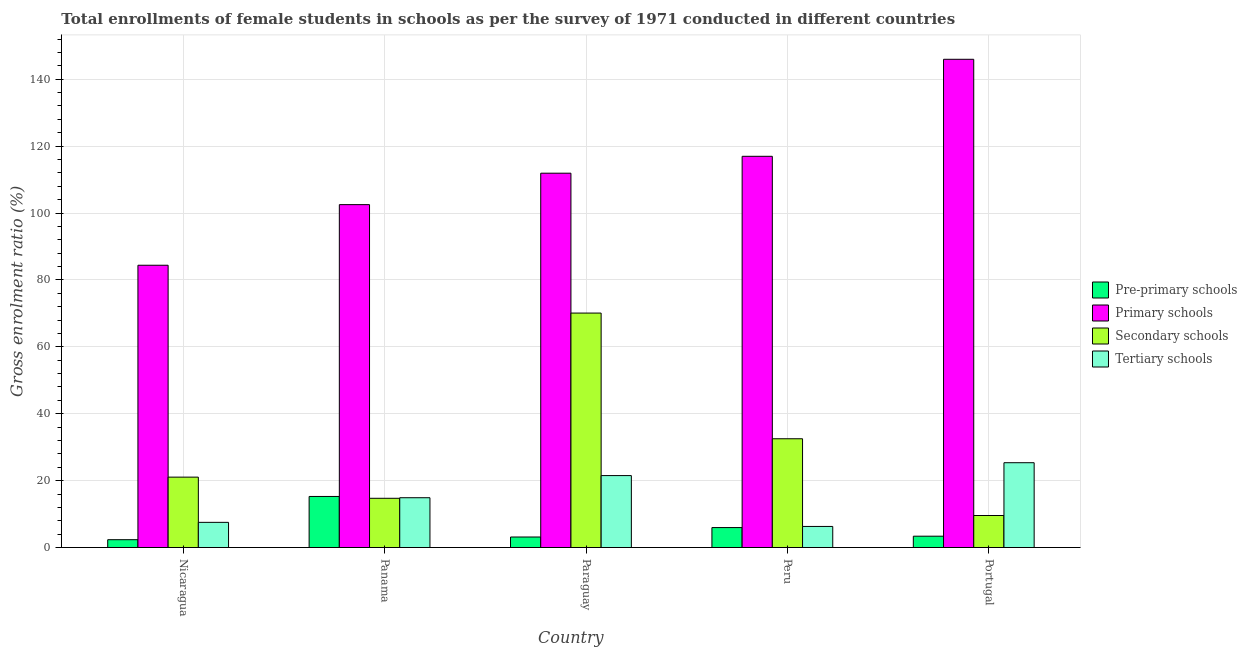How many different coloured bars are there?
Your response must be concise. 4. How many groups of bars are there?
Your answer should be very brief. 5. Are the number of bars on each tick of the X-axis equal?
Offer a terse response. Yes. How many bars are there on the 3rd tick from the left?
Keep it short and to the point. 4. What is the label of the 2nd group of bars from the left?
Your response must be concise. Panama. What is the gross enrolment ratio(female) in primary schools in Nicaragua?
Ensure brevity in your answer.  84.39. Across all countries, what is the maximum gross enrolment ratio(female) in secondary schools?
Offer a very short reply. 70.09. Across all countries, what is the minimum gross enrolment ratio(female) in secondary schools?
Keep it short and to the point. 9.57. In which country was the gross enrolment ratio(female) in pre-primary schools maximum?
Provide a succinct answer. Panama. In which country was the gross enrolment ratio(female) in primary schools minimum?
Your response must be concise. Nicaragua. What is the total gross enrolment ratio(female) in pre-primary schools in the graph?
Give a very brief answer. 30.1. What is the difference between the gross enrolment ratio(female) in secondary schools in Nicaragua and that in Peru?
Your response must be concise. -11.47. What is the difference between the gross enrolment ratio(female) in primary schools in Nicaragua and the gross enrolment ratio(female) in tertiary schools in Panama?
Offer a very short reply. 69.5. What is the average gross enrolment ratio(female) in primary schools per country?
Provide a short and direct response. 112.34. What is the difference between the gross enrolment ratio(female) in tertiary schools and gross enrolment ratio(female) in secondary schools in Panama?
Keep it short and to the point. 0.17. In how many countries, is the gross enrolment ratio(female) in pre-primary schools greater than 148 %?
Keep it short and to the point. 0. What is the ratio of the gross enrolment ratio(female) in tertiary schools in Panama to that in Portugal?
Make the answer very short. 0.59. Is the difference between the gross enrolment ratio(female) in tertiary schools in Nicaragua and Portugal greater than the difference between the gross enrolment ratio(female) in secondary schools in Nicaragua and Portugal?
Your answer should be very brief. No. What is the difference between the highest and the second highest gross enrolment ratio(female) in tertiary schools?
Keep it short and to the point. 3.85. What is the difference between the highest and the lowest gross enrolment ratio(female) in tertiary schools?
Your answer should be very brief. 19.05. In how many countries, is the gross enrolment ratio(female) in pre-primary schools greater than the average gross enrolment ratio(female) in pre-primary schools taken over all countries?
Make the answer very short. 1. Is it the case that in every country, the sum of the gross enrolment ratio(female) in pre-primary schools and gross enrolment ratio(female) in tertiary schools is greater than the sum of gross enrolment ratio(female) in secondary schools and gross enrolment ratio(female) in primary schools?
Your response must be concise. No. What does the 3rd bar from the left in Nicaragua represents?
Give a very brief answer. Secondary schools. What does the 4th bar from the right in Paraguay represents?
Make the answer very short. Pre-primary schools. How many bars are there?
Your answer should be very brief. 20. What is the difference between two consecutive major ticks on the Y-axis?
Ensure brevity in your answer.  20. Does the graph contain any zero values?
Give a very brief answer. No. Does the graph contain grids?
Your response must be concise. Yes. Where does the legend appear in the graph?
Make the answer very short. Center right. What is the title of the graph?
Offer a very short reply. Total enrollments of female students in schools as per the survey of 1971 conducted in different countries. What is the label or title of the Y-axis?
Your response must be concise. Gross enrolment ratio (%). What is the Gross enrolment ratio (%) in Pre-primary schools in Nicaragua?
Your answer should be very brief. 2.34. What is the Gross enrolment ratio (%) of Primary schools in Nicaragua?
Provide a short and direct response. 84.39. What is the Gross enrolment ratio (%) in Secondary schools in Nicaragua?
Your answer should be compact. 21.04. What is the Gross enrolment ratio (%) in Tertiary schools in Nicaragua?
Keep it short and to the point. 7.53. What is the Gross enrolment ratio (%) in Pre-primary schools in Panama?
Your answer should be very brief. 15.27. What is the Gross enrolment ratio (%) of Primary schools in Panama?
Your answer should be compact. 102.51. What is the Gross enrolment ratio (%) in Secondary schools in Panama?
Provide a short and direct response. 14.72. What is the Gross enrolment ratio (%) of Tertiary schools in Panama?
Keep it short and to the point. 14.89. What is the Gross enrolment ratio (%) in Pre-primary schools in Paraguay?
Ensure brevity in your answer.  3.14. What is the Gross enrolment ratio (%) in Primary schools in Paraguay?
Ensure brevity in your answer.  111.91. What is the Gross enrolment ratio (%) of Secondary schools in Paraguay?
Give a very brief answer. 70.09. What is the Gross enrolment ratio (%) of Tertiary schools in Paraguay?
Provide a succinct answer. 21.51. What is the Gross enrolment ratio (%) of Pre-primary schools in Peru?
Make the answer very short. 5.96. What is the Gross enrolment ratio (%) in Primary schools in Peru?
Give a very brief answer. 116.96. What is the Gross enrolment ratio (%) of Secondary schools in Peru?
Your response must be concise. 32.52. What is the Gross enrolment ratio (%) in Tertiary schools in Peru?
Keep it short and to the point. 6.3. What is the Gross enrolment ratio (%) of Pre-primary schools in Portugal?
Your answer should be compact. 3.39. What is the Gross enrolment ratio (%) in Primary schools in Portugal?
Give a very brief answer. 145.96. What is the Gross enrolment ratio (%) of Secondary schools in Portugal?
Your response must be concise. 9.57. What is the Gross enrolment ratio (%) of Tertiary schools in Portugal?
Provide a succinct answer. 25.35. Across all countries, what is the maximum Gross enrolment ratio (%) of Pre-primary schools?
Your answer should be compact. 15.27. Across all countries, what is the maximum Gross enrolment ratio (%) of Primary schools?
Provide a succinct answer. 145.96. Across all countries, what is the maximum Gross enrolment ratio (%) in Secondary schools?
Offer a very short reply. 70.09. Across all countries, what is the maximum Gross enrolment ratio (%) in Tertiary schools?
Provide a succinct answer. 25.35. Across all countries, what is the minimum Gross enrolment ratio (%) of Pre-primary schools?
Your response must be concise. 2.34. Across all countries, what is the minimum Gross enrolment ratio (%) of Primary schools?
Your answer should be very brief. 84.39. Across all countries, what is the minimum Gross enrolment ratio (%) of Secondary schools?
Offer a terse response. 9.57. Across all countries, what is the minimum Gross enrolment ratio (%) of Tertiary schools?
Your answer should be very brief. 6.3. What is the total Gross enrolment ratio (%) in Pre-primary schools in the graph?
Keep it short and to the point. 30.1. What is the total Gross enrolment ratio (%) in Primary schools in the graph?
Keep it short and to the point. 561.72. What is the total Gross enrolment ratio (%) of Secondary schools in the graph?
Ensure brevity in your answer.  147.94. What is the total Gross enrolment ratio (%) of Tertiary schools in the graph?
Offer a terse response. 75.57. What is the difference between the Gross enrolment ratio (%) of Pre-primary schools in Nicaragua and that in Panama?
Provide a short and direct response. -12.93. What is the difference between the Gross enrolment ratio (%) of Primary schools in Nicaragua and that in Panama?
Offer a very short reply. -18.12. What is the difference between the Gross enrolment ratio (%) in Secondary schools in Nicaragua and that in Panama?
Your response must be concise. 6.33. What is the difference between the Gross enrolment ratio (%) in Tertiary schools in Nicaragua and that in Panama?
Provide a succinct answer. -7.36. What is the difference between the Gross enrolment ratio (%) in Pre-primary schools in Nicaragua and that in Paraguay?
Ensure brevity in your answer.  -0.8. What is the difference between the Gross enrolment ratio (%) of Primary schools in Nicaragua and that in Paraguay?
Provide a succinct answer. -27.52. What is the difference between the Gross enrolment ratio (%) in Secondary schools in Nicaragua and that in Paraguay?
Ensure brevity in your answer.  -49.05. What is the difference between the Gross enrolment ratio (%) in Tertiary schools in Nicaragua and that in Paraguay?
Provide a succinct answer. -13.98. What is the difference between the Gross enrolment ratio (%) of Pre-primary schools in Nicaragua and that in Peru?
Your answer should be compact. -3.62. What is the difference between the Gross enrolment ratio (%) in Primary schools in Nicaragua and that in Peru?
Provide a succinct answer. -32.57. What is the difference between the Gross enrolment ratio (%) in Secondary schools in Nicaragua and that in Peru?
Make the answer very short. -11.47. What is the difference between the Gross enrolment ratio (%) of Tertiary schools in Nicaragua and that in Peru?
Your response must be concise. 1.23. What is the difference between the Gross enrolment ratio (%) in Pre-primary schools in Nicaragua and that in Portugal?
Provide a short and direct response. -1.05. What is the difference between the Gross enrolment ratio (%) in Primary schools in Nicaragua and that in Portugal?
Give a very brief answer. -61.57. What is the difference between the Gross enrolment ratio (%) of Secondary schools in Nicaragua and that in Portugal?
Provide a succinct answer. 11.47. What is the difference between the Gross enrolment ratio (%) of Tertiary schools in Nicaragua and that in Portugal?
Your answer should be very brief. -17.83. What is the difference between the Gross enrolment ratio (%) in Pre-primary schools in Panama and that in Paraguay?
Ensure brevity in your answer.  12.12. What is the difference between the Gross enrolment ratio (%) of Primary schools in Panama and that in Paraguay?
Your answer should be very brief. -9.4. What is the difference between the Gross enrolment ratio (%) of Secondary schools in Panama and that in Paraguay?
Ensure brevity in your answer.  -55.37. What is the difference between the Gross enrolment ratio (%) in Tertiary schools in Panama and that in Paraguay?
Your answer should be compact. -6.62. What is the difference between the Gross enrolment ratio (%) in Pre-primary schools in Panama and that in Peru?
Your answer should be very brief. 9.3. What is the difference between the Gross enrolment ratio (%) in Primary schools in Panama and that in Peru?
Make the answer very short. -14.45. What is the difference between the Gross enrolment ratio (%) in Secondary schools in Panama and that in Peru?
Keep it short and to the point. -17.8. What is the difference between the Gross enrolment ratio (%) of Tertiary schools in Panama and that in Peru?
Provide a succinct answer. 8.59. What is the difference between the Gross enrolment ratio (%) of Pre-primary schools in Panama and that in Portugal?
Ensure brevity in your answer.  11.88. What is the difference between the Gross enrolment ratio (%) in Primary schools in Panama and that in Portugal?
Your response must be concise. -43.45. What is the difference between the Gross enrolment ratio (%) of Secondary schools in Panama and that in Portugal?
Your answer should be compact. 5.15. What is the difference between the Gross enrolment ratio (%) of Tertiary schools in Panama and that in Portugal?
Provide a succinct answer. -10.47. What is the difference between the Gross enrolment ratio (%) in Pre-primary schools in Paraguay and that in Peru?
Provide a succinct answer. -2.82. What is the difference between the Gross enrolment ratio (%) of Primary schools in Paraguay and that in Peru?
Offer a very short reply. -5.05. What is the difference between the Gross enrolment ratio (%) in Secondary schools in Paraguay and that in Peru?
Offer a terse response. 37.58. What is the difference between the Gross enrolment ratio (%) in Tertiary schools in Paraguay and that in Peru?
Offer a very short reply. 15.21. What is the difference between the Gross enrolment ratio (%) in Pre-primary schools in Paraguay and that in Portugal?
Give a very brief answer. -0.24. What is the difference between the Gross enrolment ratio (%) of Primary schools in Paraguay and that in Portugal?
Offer a terse response. -34.05. What is the difference between the Gross enrolment ratio (%) of Secondary schools in Paraguay and that in Portugal?
Provide a short and direct response. 60.52. What is the difference between the Gross enrolment ratio (%) of Tertiary schools in Paraguay and that in Portugal?
Ensure brevity in your answer.  -3.85. What is the difference between the Gross enrolment ratio (%) of Pre-primary schools in Peru and that in Portugal?
Offer a very short reply. 2.58. What is the difference between the Gross enrolment ratio (%) of Primary schools in Peru and that in Portugal?
Make the answer very short. -29. What is the difference between the Gross enrolment ratio (%) of Secondary schools in Peru and that in Portugal?
Offer a very short reply. 22.94. What is the difference between the Gross enrolment ratio (%) of Tertiary schools in Peru and that in Portugal?
Make the answer very short. -19.05. What is the difference between the Gross enrolment ratio (%) in Pre-primary schools in Nicaragua and the Gross enrolment ratio (%) in Primary schools in Panama?
Give a very brief answer. -100.17. What is the difference between the Gross enrolment ratio (%) of Pre-primary schools in Nicaragua and the Gross enrolment ratio (%) of Secondary schools in Panama?
Offer a very short reply. -12.38. What is the difference between the Gross enrolment ratio (%) in Pre-primary schools in Nicaragua and the Gross enrolment ratio (%) in Tertiary schools in Panama?
Provide a short and direct response. -12.55. What is the difference between the Gross enrolment ratio (%) of Primary schools in Nicaragua and the Gross enrolment ratio (%) of Secondary schools in Panama?
Your answer should be compact. 69.67. What is the difference between the Gross enrolment ratio (%) of Primary schools in Nicaragua and the Gross enrolment ratio (%) of Tertiary schools in Panama?
Your answer should be very brief. 69.5. What is the difference between the Gross enrolment ratio (%) of Secondary schools in Nicaragua and the Gross enrolment ratio (%) of Tertiary schools in Panama?
Offer a terse response. 6.16. What is the difference between the Gross enrolment ratio (%) in Pre-primary schools in Nicaragua and the Gross enrolment ratio (%) in Primary schools in Paraguay?
Give a very brief answer. -109.57. What is the difference between the Gross enrolment ratio (%) in Pre-primary schools in Nicaragua and the Gross enrolment ratio (%) in Secondary schools in Paraguay?
Your answer should be compact. -67.75. What is the difference between the Gross enrolment ratio (%) of Pre-primary schools in Nicaragua and the Gross enrolment ratio (%) of Tertiary schools in Paraguay?
Your answer should be compact. -19.17. What is the difference between the Gross enrolment ratio (%) in Primary schools in Nicaragua and the Gross enrolment ratio (%) in Secondary schools in Paraguay?
Ensure brevity in your answer.  14.3. What is the difference between the Gross enrolment ratio (%) in Primary schools in Nicaragua and the Gross enrolment ratio (%) in Tertiary schools in Paraguay?
Make the answer very short. 62.88. What is the difference between the Gross enrolment ratio (%) of Secondary schools in Nicaragua and the Gross enrolment ratio (%) of Tertiary schools in Paraguay?
Offer a very short reply. -0.46. What is the difference between the Gross enrolment ratio (%) of Pre-primary schools in Nicaragua and the Gross enrolment ratio (%) of Primary schools in Peru?
Ensure brevity in your answer.  -114.62. What is the difference between the Gross enrolment ratio (%) of Pre-primary schools in Nicaragua and the Gross enrolment ratio (%) of Secondary schools in Peru?
Offer a terse response. -30.18. What is the difference between the Gross enrolment ratio (%) in Pre-primary schools in Nicaragua and the Gross enrolment ratio (%) in Tertiary schools in Peru?
Your response must be concise. -3.96. What is the difference between the Gross enrolment ratio (%) of Primary schools in Nicaragua and the Gross enrolment ratio (%) of Secondary schools in Peru?
Offer a very short reply. 51.87. What is the difference between the Gross enrolment ratio (%) in Primary schools in Nicaragua and the Gross enrolment ratio (%) in Tertiary schools in Peru?
Keep it short and to the point. 78.09. What is the difference between the Gross enrolment ratio (%) in Secondary schools in Nicaragua and the Gross enrolment ratio (%) in Tertiary schools in Peru?
Offer a terse response. 14.74. What is the difference between the Gross enrolment ratio (%) of Pre-primary schools in Nicaragua and the Gross enrolment ratio (%) of Primary schools in Portugal?
Keep it short and to the point. -143.62. What is the difference between the Gross enrolment ratio (%) of Pre-primary schools in Nicaragua and the Gross enrolment ratio (%) of Secondary schools in Portugal?
Offer a very short reply. -7.23. What is the difference between the Gross enrolment ratio (%) in Pre-primary schools in Nicaragua and the Gross enrolment ratio (%) in Tertiary schools in Portugal?
Your answer should be very brief. -23.01. What is the difference between the Gross enrolment ratio (%) in Primary schools in Nicaragua and the Gross enrolment ratio (%) in Secondary schools in Portugal?
Make the answer very short. 74.82. What is the difference between the Gross enrolment ratio (%) in Primary schools in Nicaragua and the Gross enrolment ratio (%) in Tertiary schools in Portugal?
Offer a terse response. 59.04. What is the difference between the Gross enrolment ratio (%) in Secondary schools in Nicaragua and the Gross enrolment ratio (%) in Tertiary schools in Portugal?
Offer a terse response. -4.31. What is the difference between the Gross enrolment ratio (%) of Pre-primary schools in Panama and the Gross enrolment ratio (%) of Primary schools in Paraguay?
Make the answer very short. -96.64. What is the difference between the Gross enrolment ratio (%) in Pre-primary schools in Panama and the Gross enrolment ratio (%) in Secondary schools in Paraguay?
Make the answer very short. -54.82. What is the difference between the Gross enrolment ratio (%) in Pre-primary schools in Panama and the Gross enrolment ratio (%) in Tertiary schools in Paraguay?
Your response must be concise. -6.24. What is the difference between the Gross enrolment ratio (%) in Primary schools in Panama and the Gross enrolment ratio (%) in Secondary schools in Paraguay?
Provide a short and direct response. 32.42. What is the difference between the Gross enrolment ratio (%) in Primary schools in Panama and the Gross enrolment ratio (%) in Tertiary schools in Paraguay?
Your answer should be very brief. 81. What is the difference between the Gross enrolment ratio (%) in Secondary schools in Panama and the Gross enrolment ratio (%) in Tertiary schools in Paraguay?
Give a very brief answer. -6.79. What is the difference between the Gross enrolment ratio (%) in Pre-primary schools in Panama and the Gross enrolment ratio (%) in Primary schools in Peru?
Give a very brief answer. -101.69. What is the difference between the Gross enrolment ratio (%) in Pre-primary schools in Panama and the Gross enrolment ratio (%) in Secondary schools in Peru?
Offer a very short reply. -17.25. What is the difference between the Gross enrolment ratio (%) in Pre-primary schools in Panama and the Gross enrolment ratio (%) in Tertiary schools in Peru?
Offer a very short reply. 8.97. What is the difference between the Gross enrolment ratio (%) in Primary schools in Panama and the Gross enrolment ratio (%) in Secondary schools in Peru?
Your answer should be compact. 69.99. What is the difference between the Gross enrolment ratio (%) in Primary schools in Panama and the Gross enrolment ratio (%) in Tertiary schools in Peru?
Your response must be concise. 96.21. What is the difference between the Gross enrolment ratio (%) in Secondary schools in Panama and the Gross enrolment ratio (%) in Tertiary schools in Peru?
Your answer should be compact. 8.42. What is the difference between the Gross enrolment ratio (%) of Pre-primary schools in Panama and the Gross enrolment ratio (%) of Primary schools in Portugal?
Offer a terse response. -130.69. What is the difference between the Gross enrolment ratio (%) in Pre-primary schools in Panama and the Gross enrolment ratio (%) in Secondary schools in Portugal?
Ensure brevity in your answer.  5.7. What is the difference between the Gross enrolment ratio (%) in Pre-primary schools in Panama and the Gross enrolment ratio (%) in Tertiary schools in Portugal?
Keep it short and to the point. -10.09. What is the difference between the Gross enrolment ratio (%) in Primary schools in Panama and the Gross enrolment ratio (%) in Secondary schools in Portugal?
Ensure brevity in your answer.  92.94. What is the difference between the Gross enrolment ratio (%) of Primary schools in Panama and the Gross enrolment ratio (%) of Tertiary schools in Portugal?
Give a very brief answer. 77.15. What is the difference between the Gross enrolment ratio (%) of Secondary schools in Panama and the Gross enrolment ratio (%) of Tertiary schools in Portugal?
Provide a succinct answer. -10.63. What is the difference between the Gross enrolment ratio (%) in Pre-primary schools in Paraguay and the Gross enrolment ratio (%) in Primary schools in Peru?
Your answer should be compact. -113.81. What is the difference between the Gross enrolment ratio (%) in Pre-primary schools in Paraguay and the Gross enrolment ratio (%) in Secondary schools in Peru?
Give a very brief answer. -29.37. What is the difference between the Gross enrolment ratio (%) of Pre-primary schools in Paraguay and the Gross enrolment ratio (%) of Tertiary schools in Peru?
Offer a very short reply. -3.16. What is the difference between the Gross enrolment ratio (%) in Primary schools in Paraguay and the Gross enrolment ratio (%) in Secondary schools in Peru?
Keep it short and to the point. 79.39. What is the difference between the Gross enrolment ratio (%) of Primary schools in Paraguay and the Gross enrolment ratio (%) of Tertiary schools in Peru?
Provide a succinct answer. 105.61. What is the difference between the Gross enrolment ratio (%) of Secondary schools in Paraguay and the Gross enrolment ratio (%) of Tertiary schools in Peru?
Give a very brief answer. 63.79. What is the difference between the Gross enrolment ratio (%) of Pre-primary schools in Paraguay and the Gross enrolment ratio (%) of Primary schools in Portugal?
Offer a terse response. -142.81. What is the difference between the Gross enrolment ratio (%) in Pre-primary schools in Paraguay and the Gross enrolment ratio (%) in Secondary schools in Portugal?
Your response must be concise. -6.43. What is the difference between the Gross enrolment ratio (%) in Pre-primary schools in Paraguay and the Gross enrolment ratio (%) in Tertiary schools in Portugal?
Ensure brevity in your answer.  -22.21. What is the difference between the Gross enrolment ratio (%) of Primary schools in Paraguay and the Gross enrolment ratio (%) of Secondary schools in Portugal?
Provide a succinct answer. 102.34. What is the difference between the Gross enrolment ratio (%) in Primary schools in Paraguay and the Gross enrolment ratio (%) in Tertiary schools in Portugal?
Your response must be concise. 86.55. What is the difference between the Gross enrolment ratio (%) of Secondary schools in Paraguay and the Gross enrolment ratio (%) of Tertiary schools in Portugal?
Offer a very short reply. 44.74. What is the difference between the Gross enrolment ratio (%) in Pre-primary schools in Peru and the Gross enrolment ratio (%) in Primary schools in Portugal?
Your response must be concise. -139.99. What is the difference between the Gross enrolment ratio (%) in Pre-primary schools in Peru and the Gross enrolment ratio (%) in Secondary schools in Portugal?
Give a very brief answer. -3.61. What is the difference between the Gross enrolment ratio (%) of Pre-primary schools in Peru and the Gross enrolment ratio (%) of Tertiary schools in Portugal?
Your answer should be very brief. -19.39. What is the difference between the Gross enrolment ratio (%) in Primary schools in Peru and the Gross enrolment ratio (%) in Secondary schools in Portugal?
Provide a succinct answer. 107.38. What is the difference between the Gross enrolment ratio (%) of Primary schools in Peru and the Gross enrolment ratio (%) of Tertiary schools in Portugal?
Provide a succinct answer. 91.6. What is the difference between the Gross enrolment ratio (%) of Secondary schools in Peru and the Gross enrolment ratio (%) of Tertiary schools in Portugal?
Your response must be concise. 7.16. What is the average Gross enrolment ratio (%) in Pre-primary schools per country?
Keep it short and to the point. 6.02. What is the average Gross enrolment ratio (%) of Primary schools per country?
Your answer should be compact. 112.34. What is the average Gross enrolment ratio (%) in Secondary schools per country?
Give a very brief answer. 29.59. What is the average Gross enrolment ratio (%) of Tertiary schools per country?
Provide a succinct answer. 15.11. What is the difference between the Gross enrolment ratio (%) in Pre-primary schools and Gross enrolment ratio (%) in Primary schools in Nicaragua?
Provide a succinct answer. -82.05. What is the difference between the Gross enrolment ratio (%) in Pre-primary schools and Gross enrolment ratio (%) in Secondary schools in Nicaragua?
Make the answer very short. -18.7. What is the difference between the Gross enrolment ratio (%) of Pre-primary schools and Gross enrolment ratio (%) of Tertiary schools in Nicaragua?
Ensure brevity in your answer.  -5.19. What is the difference between the Gross enrolment ratio (%) in Primary schools and Gross enrolment ratio (%) in Secondary schools in Nicaragua?
Keep it short and to the point. 63.35. What is the difference between the Gross enrolment ratio (%) of Primary schools and Gross enrolment ratio (%) of Tertiary schools in Nicaragua?
Keep it short and to the point. 76.86. What is the difference between the Gross enrolment ratio (%) in Secondary schools and Gross enrolment ratio (%) in Tertiary schools in Nicaragua?
Provide a short and direct response. 13.52. What is the difference between the Gross enrolment ratio (%) of Pre-primary schools and Gross enrolment ratio (%) of Primary schools in Panama?
Give a very brief answer. -87.24. What is the difference between the Gross enrolment ratio (%) in Pre-primary schools and Gross enrolment ratio (%) in Secondary schools in Panama?
Provide a succinct answer. 0.55. What is the difference between the Gross enrolment ratio (%) of Pre-primary schools and Gross enrolment ratio (%) of Tertiary schools in Panama?
Your answer should be very brief. 0.38. What is the difference between the Gross enrolment ratio (%) in Primary schools and Gross enrolment ratio (%) in Secondary schools in Panama?
Make the answer very short. 87.79. What is the difference between the Gross enrolment ratio (%) of Primary schools and Gross enrolment ratio (%) of Tertiary schools in Panama?
Your response must be concise. 87.62. What is the difference between the Gross enrolment ratio (%) of Secondary schools and Gross enrolment ratio (%) of Tertiary schools in Panama?
Your answer should be compact. -0.17. What is the difference between the Gross enrolment ratio (%) of Pre-primary schools and Gross enrolment ratio (%) of Primary schools in Paraguay?
Your response must be concise. -108.76. What is the difference between the Gross enrolment ratio (%) of Pre-primary schools and Gross enrolment ratio (%) of Secondary schools in Paraguay?
Give a very brief answer. -66.95. What is the difference between the Gross enrolment ratio (%) of Pre-primary schools and Gross enrolment ratio (%) of Tertiary schools in Paraguay?
Your answer should be very brief. -18.36. What is the difference between the Gross enrolment ratio (%) of Primary schools and Gross enrolment ratio (%) of Secondary schools in Paraguay?
Keep it short and to the point. 41.82. What is the difference between the Gross enrolment ratio (%) in Primary schools and Gross enrolment ratio (%) in Tertiary schools in Paraguay?
Offer a very short reply. 90.4. What is the difference between the Gross enrolment ratio (%) in Secondary schools and Gross enrolment ratio (%) in Tertiary schools in Paraguay?
Keep it short and to the point. 48.59. What is the difference between the Gross enrolment ratio (%) in Pre-primary schools and Gross enrolment ratio (%) in Primary schools in Peru?
Provide a succinct answer. -110.99. What is the difference between the Gross enrolment ratio (%) of Pre-primary schools and Gross enrolment ratio (%) of Secondary schools in Peru?
Offer a terse response. -26.55. What is the difference between the Gross enrolment ratio (%) in Pre-primary schools and Gross enrolment ratio (%) in Tertiary schools in Peru?
Offer a terse response. -0.34. What is the difference between the Gross enrolment ratio (%) of Primary schools and Gross enrolment ratio (%) of Secondary schools in Peru?
Give a very brief answer. 84.44. What is the difference between the Gross enrolment ratio (%) in Primary schools and Gross enrolment ratio (%) in Tertiary schools in Peru?
Provide a short and direct response. 110.66. What is the difference between the Gross enrolment ratio (%) of Secondary schools and Gross enrolment ratio (%) of Tertiary schools in Peru?
Your answer should be compact. 26.22. What is the difference between the Gross enrolment ratio (%) in Pre-primary schools and Gross enrolment ratio (%) in Primary schools in Portugal?
Your answer should be very brief. -142.57. What is the difference between the Gross enrolment ratio (%) in Pre-primary schools and Gross enrolment ratio (%) in Secondary schools in Portugal?
Your answer should be compact. -6.19. What is the difference between the Gross enrolment ratio (%) in Pre-primary schools and Gross enrolment ratio (%) in Tertiary schools in Portugal?
Your response must be concise. -21.97. What is the difference between the Gross enrolment ratio (%) in Primary schools and Gross enrolment ratio (%) in Secondary schools in Portugal?
Your response must be concise. 136.39. What is the difference between the Gross enrolment ratio (%) of Primary schools and Gross enrolment ratio (%) of Tertiary schools in Portugal?
Offer a very short reply. 120.61. What is the difference between the Gross enrolment ratio (%) in Secondary schools and Gross enrolment ratio (%) in Tertiary schools in Portugal?
Keep it short and to the point. -15.78. What is the ratio of the Gross enrolment ratio (%) of Pre-primary schools in Nicaragua to that in Panama?
Your answer should be very brief. 0.15. What is the ratio of the Gross enrolment ratio (%) of Primary schools in Nicaragua to that in Panama?
Offer a terse response. 0.82. What is the ratio of the Gross enrolment ratio (%) of Secondary schools in Nicaragua to that in Panama?
Offer a very short reply. 1.43. What is the ratio of the Gross enrolment ratio (%) in Tertiary schools in Nicaragua to that in Panama?
Provide a succinct answer. 0.51. What is the ratio of the Gross enrolment ratio (%) in Pre-primary schools in Nicaragua to that in Paraguay?
Ensure brevity in your answer.  0.74. What is the ratio of the Gross enrolment ratio (%) of Primary schools in Nicaragua to that in Paraguay?
Provide a short and direct response. 0.75. What is the ratio of the Gross enrolment ratio (%) in Secondary schools in Nicaragua to that in Paraguay?
Ensure brevity in your answer.  0.3. What is the ratio of the Gross enrolment ratio (%) of Pre-primary schools in Nicaragua to that in Peru?
Offer a terse response. 0.39. What is the ratio of the Gross enrolment ratio (%) in Primary schools in Nicaragua to that in Peru?
Give a very brief answer. 0.72. What is the ratio of the Gross enrolment ratio (%) in Secondary schools in Nicaragua to that in Peru?
Keep it short and to the point. 0.65. What is the ratio of the Gross enrolment ratio (%) in Tertiary schools in Nicaragua to that in Peru?
Offer a very short reply. 1.19. What is the ratio of the Gross enrolment ratio (%) in Pre-primary schools in Nicaragua to that in Portugal?
Provide a short and direct response. 0.69. What is the ratio of the Gross enrolment ratio (%) of Primary schools in Nicaragua to that in Portugal?
Give a very brief answer. 0.58. What is the ratio of the Gross enrolment ratio (%) of Secondary schools in Nicaragua to that in Portugal?
Your answer should be compact. 2.2. What is the ratio of the Gross enrolment ratio (%) of Tertiary schools in Nicaragua to that in Portugal?
Offer a very short reply. 0.3. What is the ratio of the Gross enrolment ratio (%) in Pre-primary schools in Panama to that in Paraguay?
Your answer should be very brief. 4.86. What is the ratio of the Gross enrolment ratio (%) in Primary schools in Panama to that in Paraguay?
Keep it short and to the point. 0.92. What is the ratio of the Gross enrolment ratio (%) in Secondary schools in Panama to that in Paraguay?
Give a very brief answer. 0.21. What is the ratio of the Gross enrolment ratio (%) in Tertiary schools in Panama to that in Paraguay?
Provide a succinct answer. 0.69. What is the ratio of the Gross enrolment ratio (%) in Pre-primary schools in Panama to that in Peru?
Provide a short and direct response. 2.56. What is the ratio of the Gross enrolment ratio (%) in Primary schools in Panama to that in Peru?
Your answer should be very brief. 0.88. What is the ratio of the Gross enrolment ratio (%) in Secondary schools in Panama to that in Peru?
Your response must be concise. 0.45. What is the ratio of the Gross enrolment ratio (%) of Tertiary schools in Panama to that in Peru?
Make the answer very short. 2.36. What is the ratio of the Gross enrolment ratio (%) of Pre-primary schools in Panama to that in Portugal?
Your answer should be compact. 4.51. What is the ratio of the Gross enrolment ratio (%) of Primary schools in Panama to that in Portugal?
Make the answer very short. 0.7. What is the ratio of the Gross enrolment ratio (%) in Secondary schools in Panama to that in Portugal?
Give a very brief answer. 1.54. What is the ratio of the Gross enrolment ratio (%) of Tertiary schools in Panama to that in Portugal?
Your answer should be compact. 0.59. What is the ratio of the Gross enrolment ratio (%) in Pre-primary schools in Paraguay to that in Peru?
Give a very brief answer. 0.53. What is the ratio of the Gross enrolment ratio (%) of Primary schools in Paraguay to that in Peru?
Keep it short and to the point. 0.96. What is the ratio of the Gross enrolment ratio (%) of Secondary schools in Paraguay to that in Peru?
Keep it short and to the point. 2.16. What is the ratio of the Gross enrolment ratio (%) of Tertiary schools in Paraguay to that in Peru?
Keep it short and to the point. 3.41. What is the ratio of the Gross enrolment ratio (%) in Pre-primary schools in Paraguay to that in Portugal?
Your answer should be very brief. 0.93. What is the ratio of the Gross enrolment ratio (%) in Primary schools in Paraguay to that in Portugal?
Your response must be concise. 0.77. What is the ratio of the Gross enrolment ratio (%) of Secondary schools in Paraguay to that in Portugal?
Ensure brevity in your answer.  7.32. What is the ratio of the Gross enrolment ratio (%) of Tertiary schools in Paraguay to that in Portugal?
Offer a very short reply. 0.85. What is the ratio of the Gross enrolment ratio (%) in Pre-primary schools in Peru to that in Portugal?
Your answer should be very brief. 1.76. What is the ratio of the Gross enrolment ratio (%) of Primary schools in Peru to that in Portugal?
Make the answer very short. 0.8. What is the ratio of the Gross enrolment ratio (%) of Secondary schools in Peru to that in Portugal?
Provide a short and direct response. 3.4. What is the ratio of the Gross enrolment ratio (%) in Tertiary schools in Peru to that in Portugal?
Offer a very short reply. 0.25. What is the difference between the highest and the second highest Gross enrolment ratio (%) of Pre-primary schools?
Give a very brief answer. 9.3. What is the difference between the highest and the second highest Gross enrolment ratio (%) of Primary schools?
Provide a succinct answer. 29. What is the difference between the highest and the second highest Gross enrolment ratio (%) in Secondary schools?
Offer a very short reply. 37.58. What is the difference between the highest and the second highest Gross enrolment ratio (%) of Tertiary schools?
Give a very brief answer. 3.85. What is the difference between the highest and the lowest Gross enrolment ratio (%) of Pre-primary schools?
Ensure brevity in your answer.  12.93. What is the difference between the highest and the lowest Gross enrolment ratio (%) of Primary schools?
Your response must be concise. 61.57. What is the difference between the highest and the lowest Gross enrolment ratio (%) of Secondary schools?
Ensure brevity in your answer.  60.52. What is the difference between the highest and the lowest Gross enrolment ratio (%) of Tertiary schools?
Offer a terse response. 19.05. 